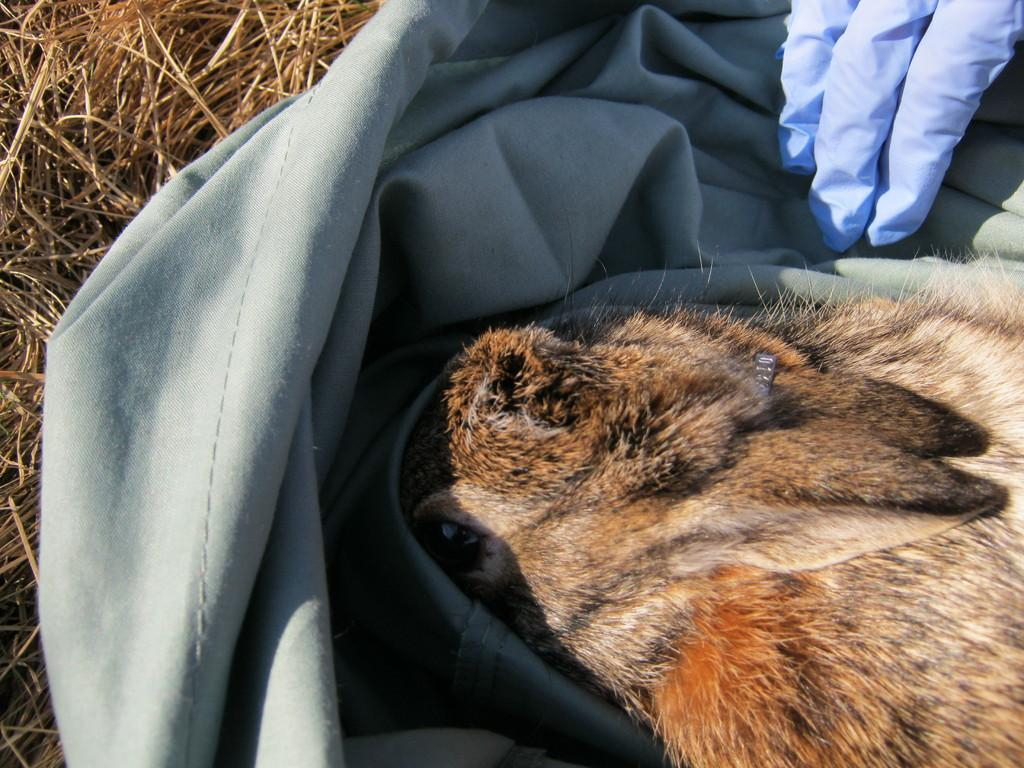What type of animal is in the image? There is a rabbit in the image. What object is also present in the image? There is a bag in the image. Whose hand can be seen in the image? A person's hand is visible in the image. What type of vegetation is in the image? There is dry grass in the image. How many pizzas are being held by the rabbit in the image? There are no pizzas present in the image; it features a rabbit, a bag, a person's hand, and dry grass. 